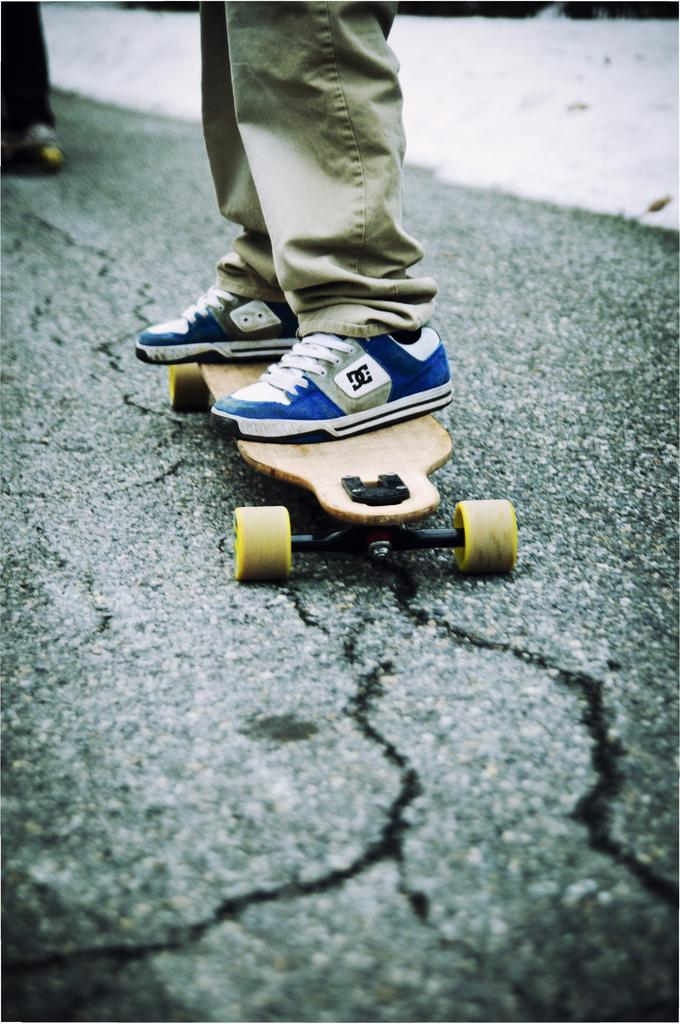Who is present in the image? There is a person in the image. What type of clothing is the person wearing? The person is wearing trousers and shoes. What is the person standing on in the image? The person is standing on a skateboard. Where is the skateboard located? The skateboard is on the road. What type of cheese is being used as a property in the competition depicted in the image? There is no cheese or competition present in the image; it features a person standing on a skateboard on the road. 